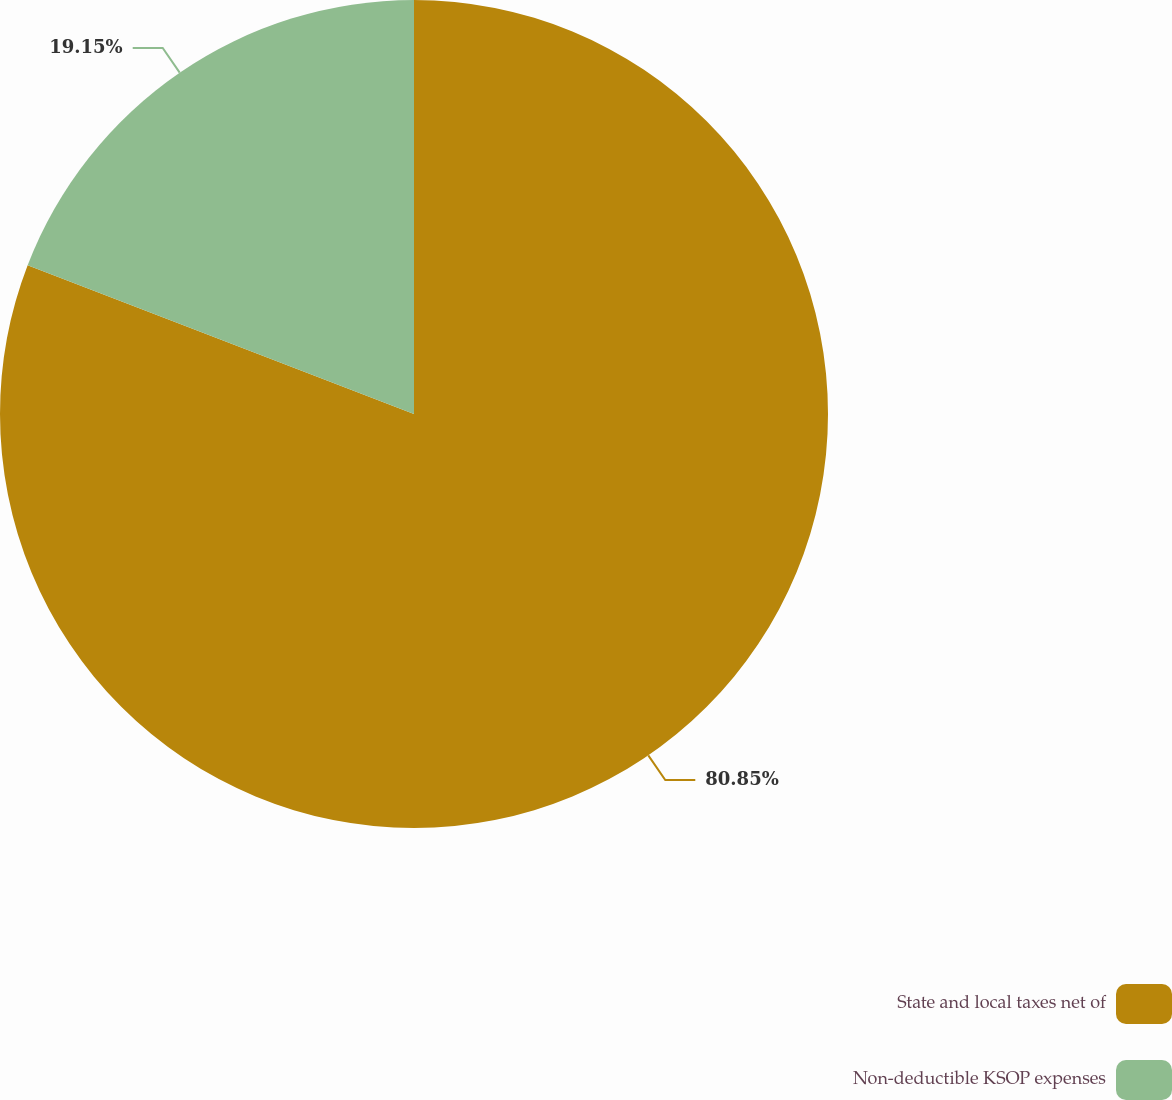<chart> <loc_0><loc_0><loc_500><loc_500><pie_chart><fcel>State and local taxes net of<fcel>Non-deductible KSOP expenses<nl><fcel>80.85%<fcel>19.15%<nl></chart> 